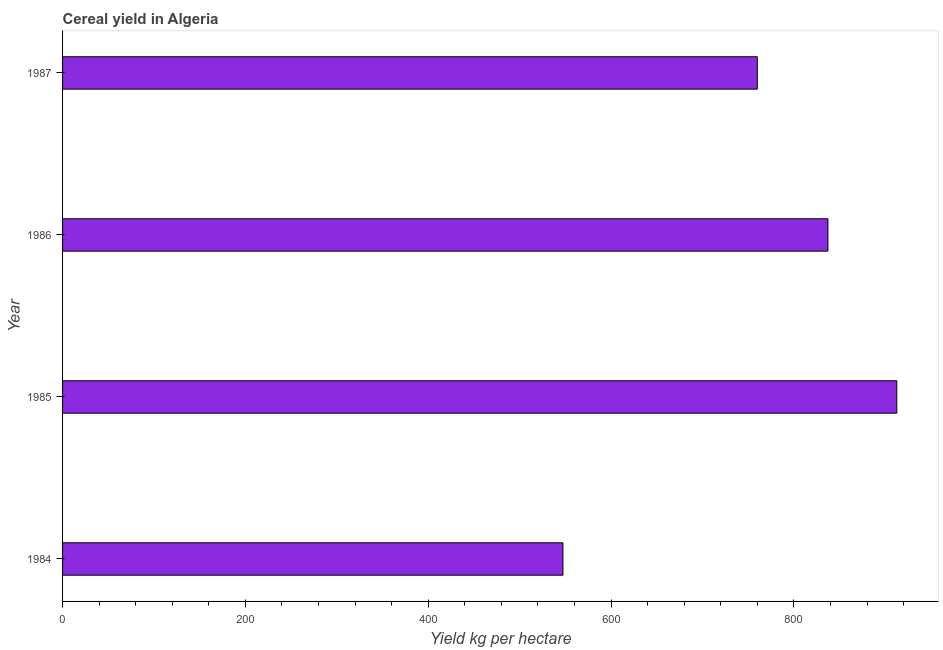Does the graph contain any zero values?
Make the answer very short. No. Does the graph contain grids?
Provide a succinct answer. No. What is the title of the graph?
Ensure brevity in your answer.  Cereal yield in Algeria. What is the label or title of the X-axis?
Your answer should be very brief. Yield kg per hectare. What is the label or title of the Y-axis?
Give a very brief answer. Year. What is the cereal yield in 1985?
Your response must be concise. 912.5. Across all years, what is the maximum cereal yield?
Provide a short and direct response. 912.5. Across all years, what is the minimum cereal yield?
Make the answer very short. 547.36. In which year was the cereal yield minimum?
Make the answer very short. 1984. What is the sum of the cereal yield?
Give a very brief answer. 3056.95. What is the difference between the cereal yield in 1984 and 1986?
Provide a short and direct response. -289.82. What is the average cereal yield per year?
Ensure brevity in your answer.  764.24. What is the median cereal yield?
Your answer should be very brief. 798.55. In how many years, is the cereal yield greater than 200 kg per hectare?
Provide a succinct answer. 4. Do a majority of the years between 1984 and 1985 (inclusive) have cereal yield greater than 440 kg per hectare?
Keep it short and to the point. Yes. What is the ratio of the cereal yield in 1984 to that in 1987?
Make the answer very short. 0.72. Is the cereal yield in 1985 less than that in 1987?
Offer a very short reply. No. What is the difference between the highest and the second highest cereal yield?
Your answer should be compact. 75.32. What is the difference between the highest and the lowest cereal yield?
Offer a terse response. 365.14. In how many years, is the cereal yield greater than the average cereal yield taken over all years?
Ensure brevity in your answer.  2. How many bars are there?
Your response must be concise. 4. Are all the bars in the graph horizontal?
Offer a very short reply. Yes. How many years are there in the graph?
Offer a terse response. 4. What is the Yield kg per hectare in 1984?
Make the answer very short. 547.36. What is the Yield kg per hectare in 1985?
Offer a terse response. 912.5. What is the Yield kg per hectare of 1986?
Your response must be concise. 837.17. What is the Yield kg per hectare of 1987?
Provide a succinct answer. 759.92. What is the difference between the Yield kg per hectare in 1984 and 1985?
Give a very brief answer. -365.14. What is the difference between the Yield kg per hectare in 1984 and 1986?
Your answer should be compact. -289.82. What is the difference between the Yield kg per hectare in 1984 and 1987?
Your answer should be compact. -212.56. What is the difference between the Yield kg per hectare in 1985 and 1986?
Provide a short and direct response. 75.32. What is the difference between the Yield kg per hectare in 1985 and 1987?
Give a very brief answer. 152.57. What is the difference between the Yield kg per hectare in 1986 and 1987?
Keep it short and to the point. 77.25. What is the ratio of the Yield kg per hectare in 1984 to that in 1986?
Ensure brevity in your answer.  0.65. What is the ratio of the Yield kg per hectare in 1984 to that in 1987?
Your response must be concise. 0.72. What is the ratio of the Yield kg per hectare in 1985 to that in 1986?
Provide a short and direct response. 1.09. What is the ratio of the Yield kg per hectare in 1985 to that in 1987?
Keep it short and to the point. 1.2. What is the ratio of the Yield kg per hectare in 1986 to that in 1987?
Provide a short and direct response. 1.1. 